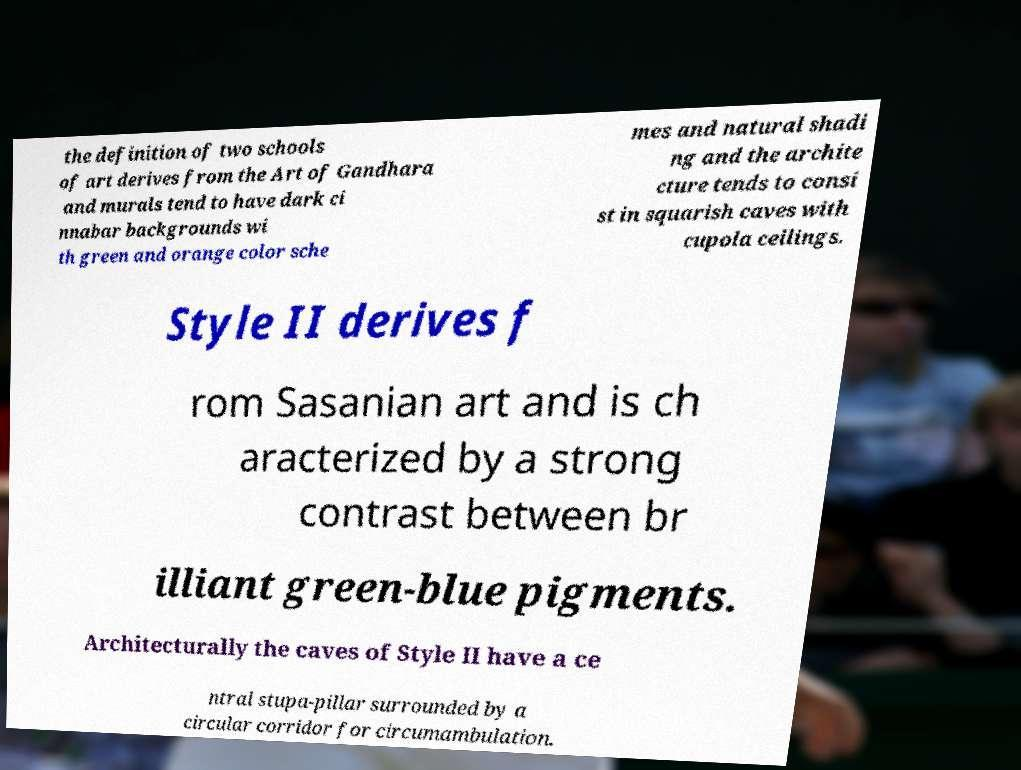There's text embedded in this image that I need extracted. Can you transcribe it verbatim? the definition of two schools of art derives from the Art of Gandhara and murals tend to have dark ci nnabar backgrounds wi th green and orange color sche mes and natural shadi ng and the archite cture tends to consi st in squarish caves with cupola ceilings. Style II derives f rom Sasanian art and is ch aracterized by a strong contrast between br illiant green-blue pigments. Architecturally the caves of Style II have a ce ntral stupa-pillar surrounded by a circular corridor for circumambulation. 